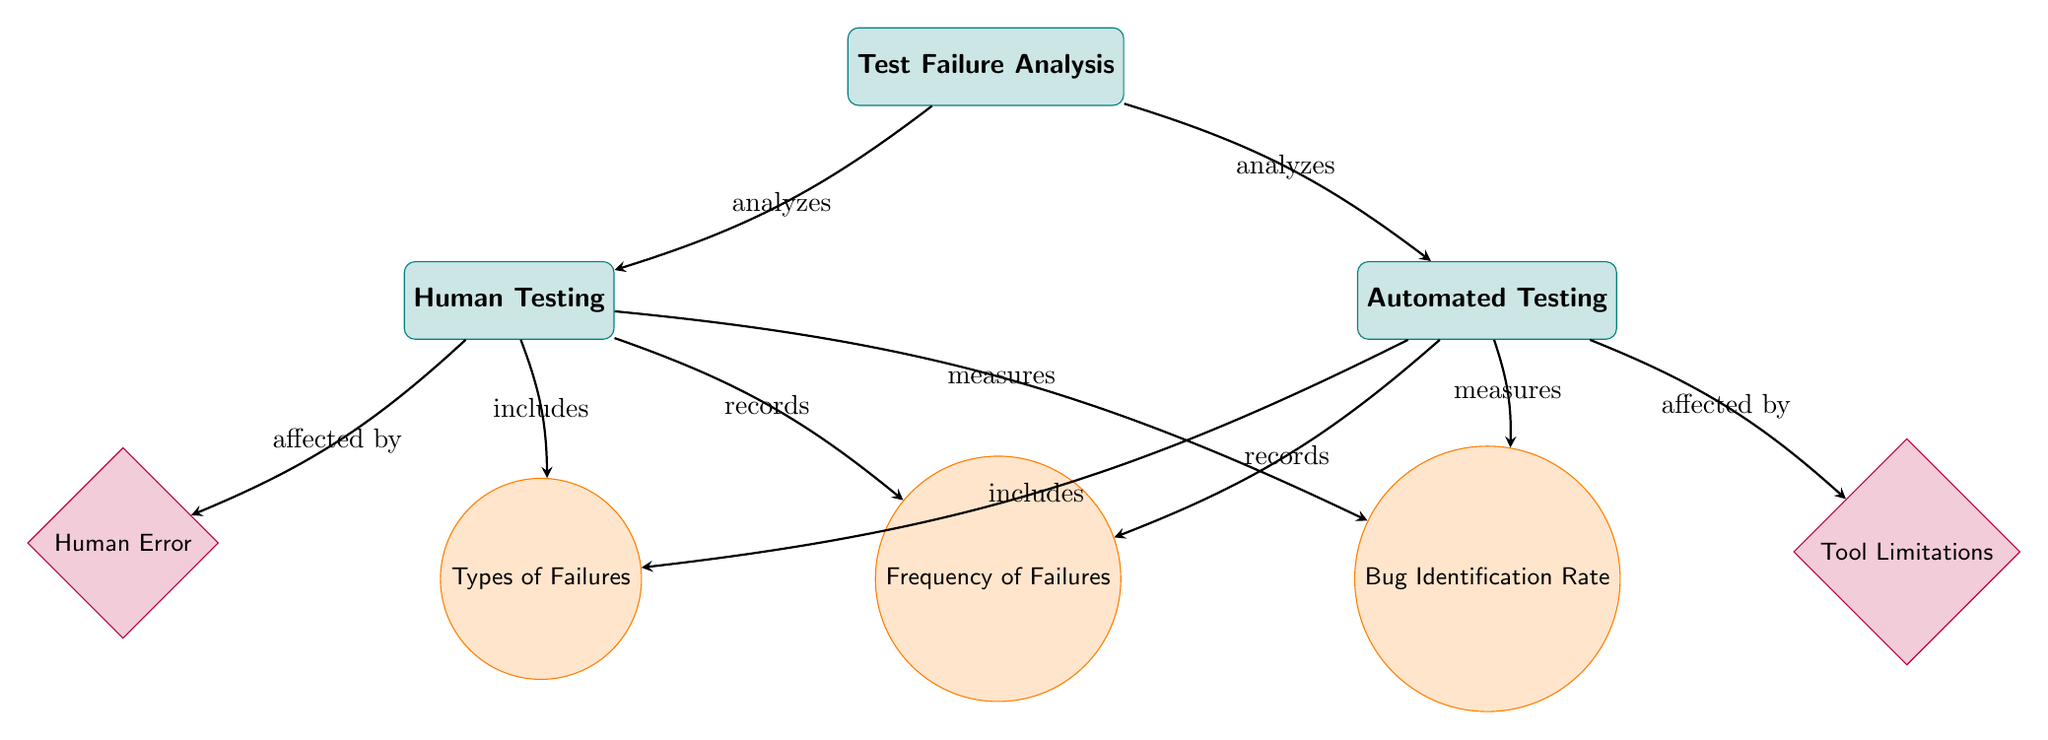What is the main category represented in the diagram? The main category node at the top of the diagram is "Test Failure Analysis," which encompasses the analysis process.
Answer: Test Failure Analysis How many types of failures are listed? The diagram indicates there are two nodes connecting to "Types of Failures": "Human Error" and "Tool Limitations," totaling two types of failures.
Answer: 2 What does the "Human Testing" node measure? The "Human Testing" node measures "Bug Identification Rate," as indicated by the edge connecting these two nodes.
Answer: Bug Identification Rate Which factor affects Human Testing? The "Human Error" node, which connects as a factor affecting "Human Testing," is identified in the diagram.
Answer: Human Error Which type of testing records the frequency of failures? Both "Human Testing" and "Automated Testing" nodes lead to the "Frequency of Failures" node, indicating both types record this metric.
Answer: Both What is the relationship between "Human Testing" and "Types of Failures"? The edge from "Human Testing" to "Types of Failures" is labeled "includes," indicating it encompasses specific failure types.
Answer: includes What is the metric associated with "Automated Testing"? The metric associated with "Automated Testing" is "Bug Identification Rate," as denoted by the connection between the two nodes.
Answer: Bug Identification Rate Which factors are associated with the types of testing? "Human Error" is associated with "Human Testing," while "Tool Limitations" is associated with "Automated Testing," showing different challenges in each.
Answer: Human Error, Tool Limitations What does the edge label indicate for the connection between "Test Failure Analysis" and "Automated Testing"? The edge label indicates "analyzes," meaning the analysis of test failures includes evaluations of automated testing.
Answer: analyzes 